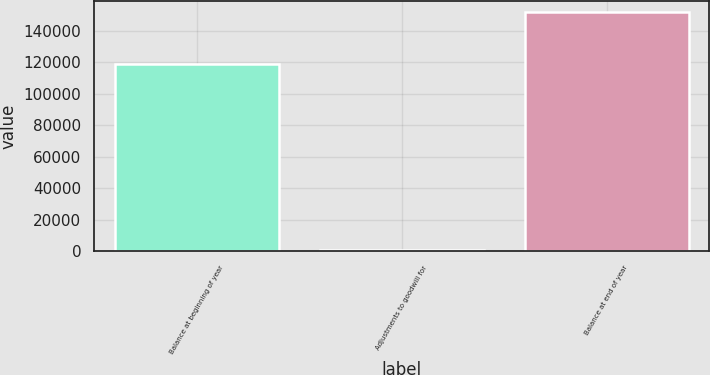<chart> <loc_0><loc_0><loc_500><loc_500><bar_chart><fcel>Balance at beginning of year<fcel>Adjustments to goodwill for<fcel>Balance at end of year<nl><fcel>118791<fcel>649<fcel>151712<nl></chart> 